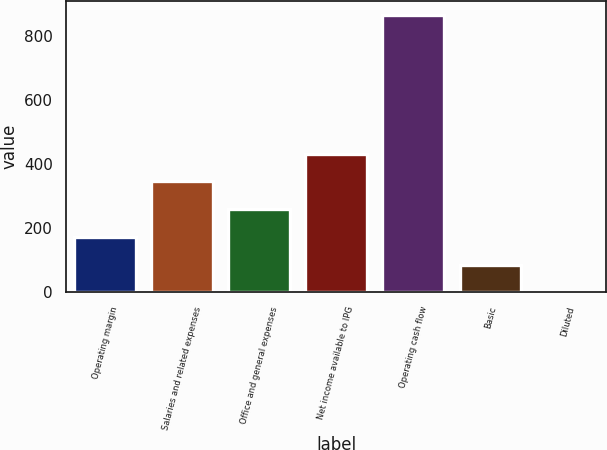<chart> <loc_0><loc_0><loc_500><loc_500><bar_chart><fcel>Operating margin<fcel>Salaries and related expenses<fcel>Office and general expenses<fcel>Net income available to IPG<fcel>Operating cash flow<fcel>Basic<fcel>Diluted<nl><fcel>173.48<fcel>346.44<fcel>259.96<fcel>432.92<fcel>865.3<fcel>87<fcel>0.52<nl></chart> 